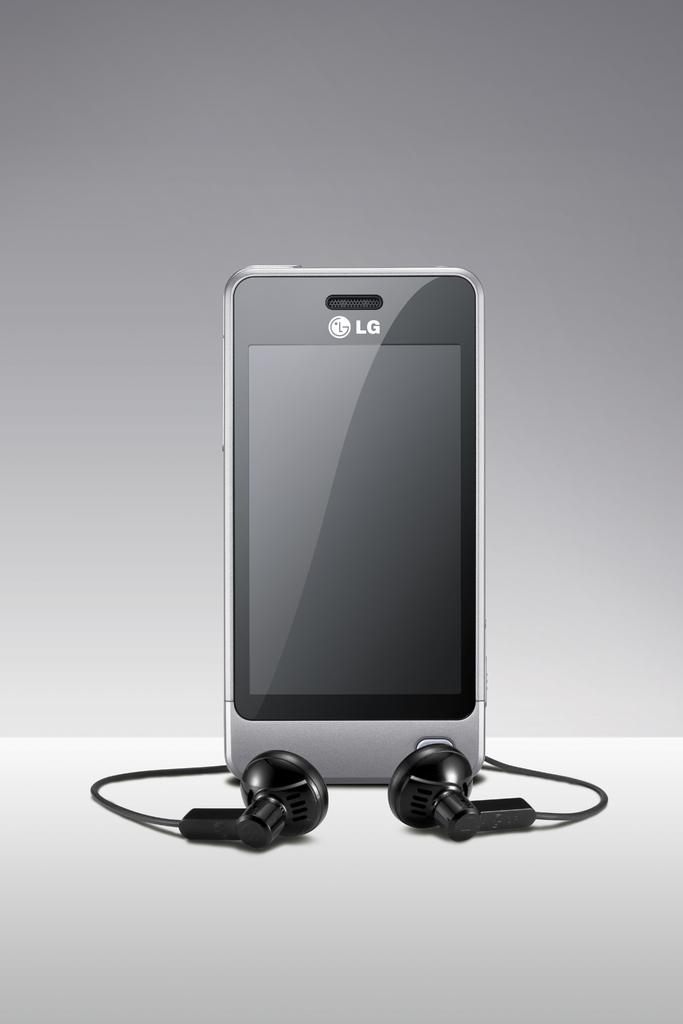What brand of mp3 player is shown?
Your answer should be compact. Lg. What company is the brand of this mp3 player?
Provide a short and direct response. Lg. 